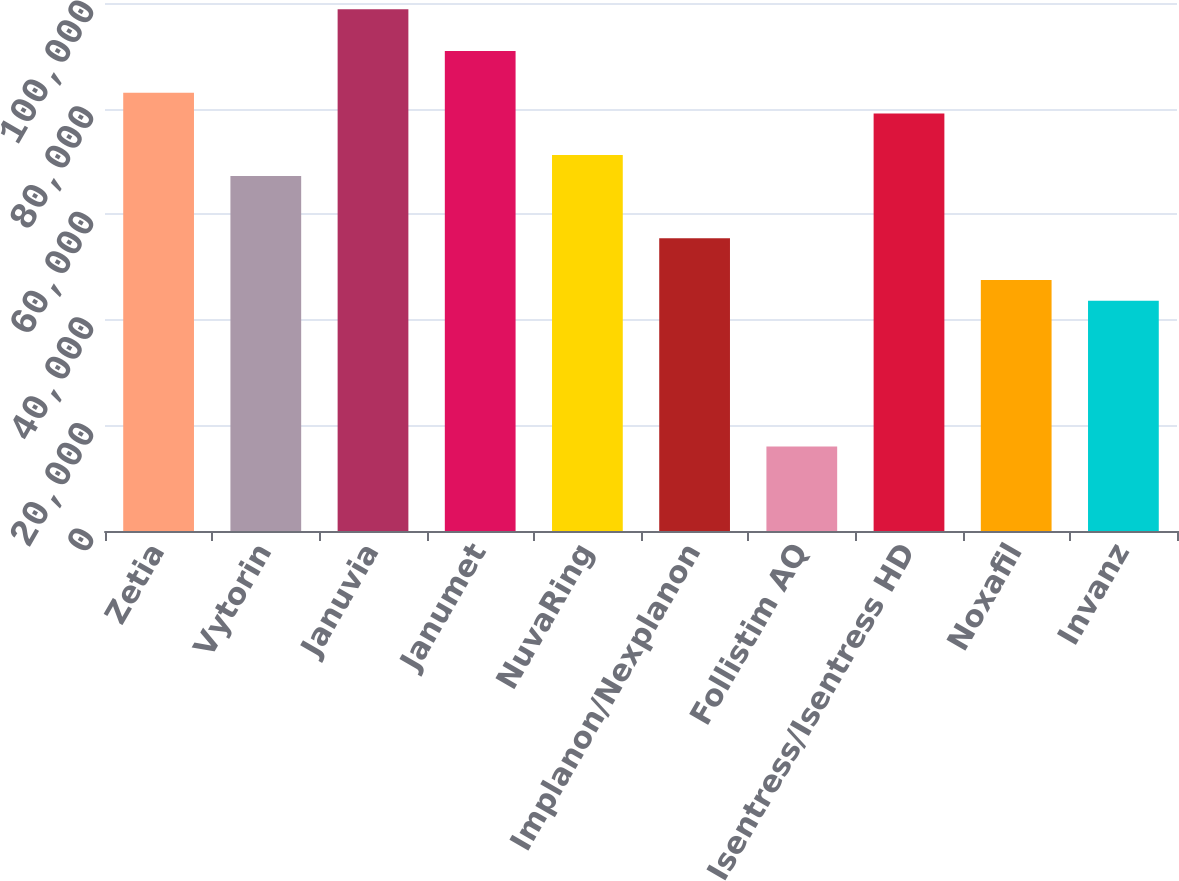Convert chart to OTSL. <chart><loc_0><loc_0><loc_500><loc_500><bar_chart><fcel>Zetia<fcel>Vytorin<fcel>Januvia<fcel>Janumet<fcel>NuvaRing<fcel>Implanon/Nexplanon<fcel>Follistim AQ<fcel>Isentress/Isentress HD<fcel>Noxafil<fcel>Invanz<nl><fcel>83025.1<fcel>67256.7<fcel>98793.5<fcel>90909.3<fcel>71198.8<fcel>55430.4<fcel>16009.4<fcel>79083<fcel>47546.2<fcel>43604.1<nl></chart> 